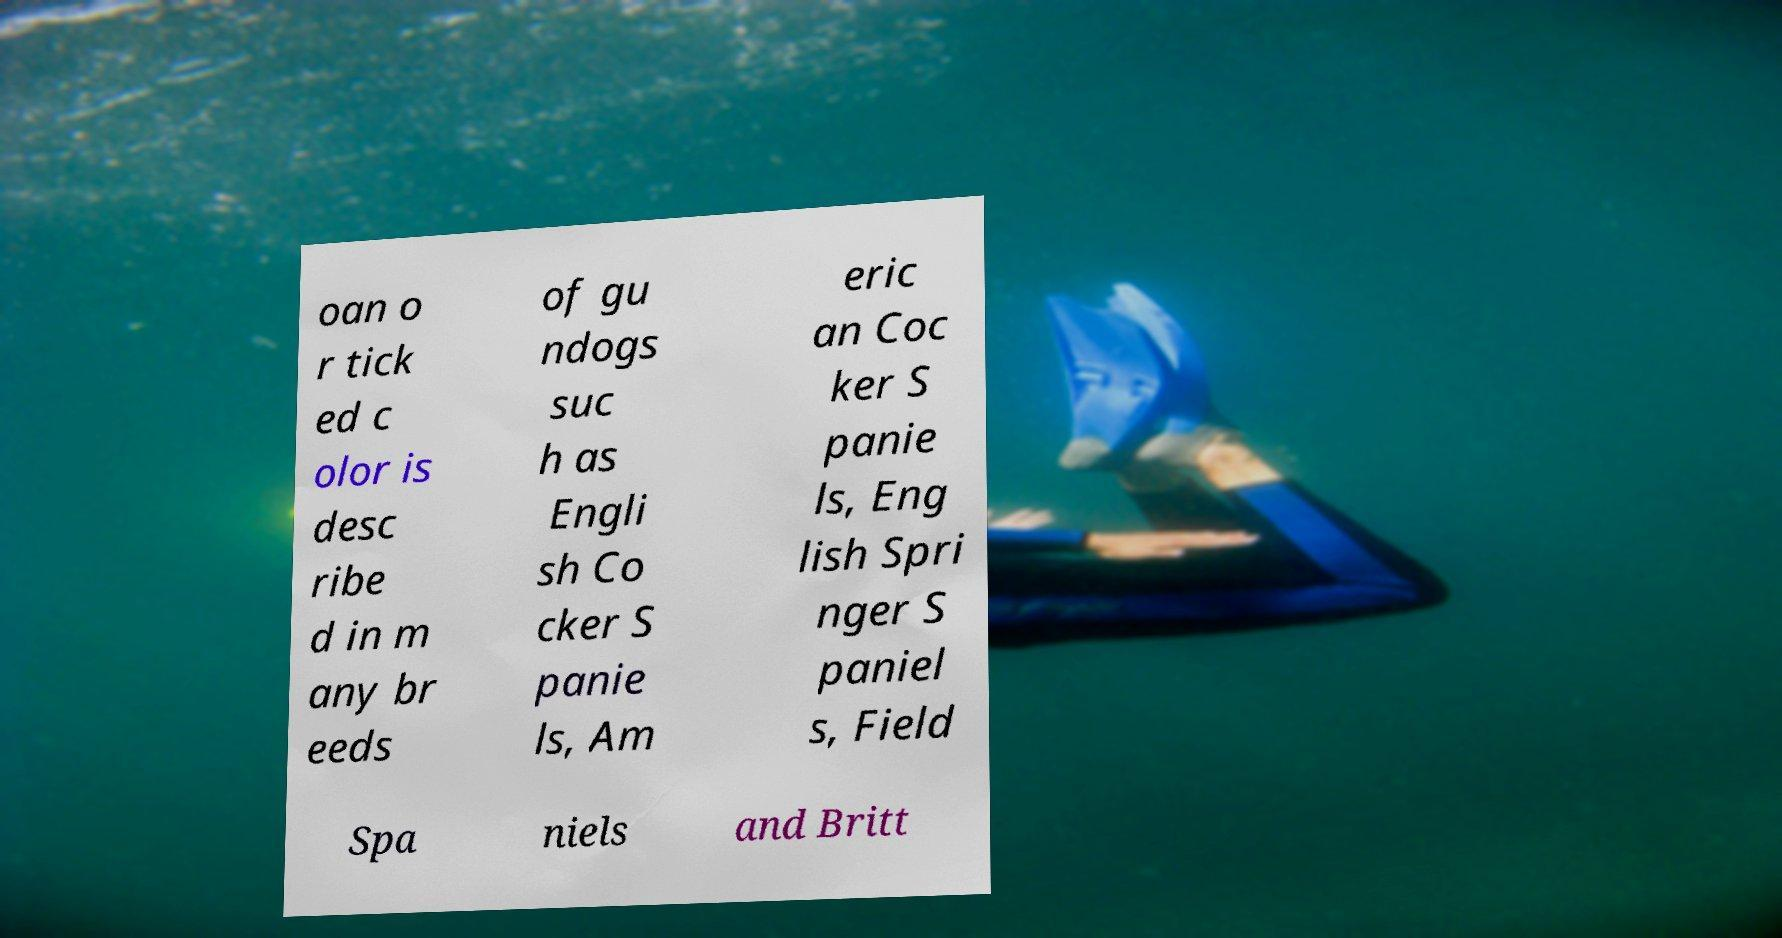What messages or text are displayed in this image? I need them in a readable, typed format. oan o r tick ed c olor is desc ribe d in m any br eeds of gu ndogs suc h as Engli sh Co cker S panie ls, Am eric an Coc ker S panie ls, Eng lish Spri nger S paniel s, Field Spa niels and Britt 